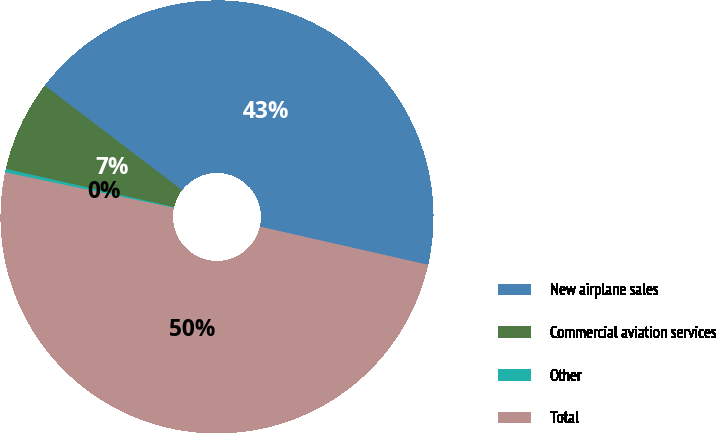Convert chart. <chart><loc_0><loc_0><loc_500><loc_500><pie_chart><fcel>New airplane sales<fcel>Commercial aviation services<fcel>Other<fcel>Total<nl><fcel>43.19%<fcel>6.81%<fcel>0.26%<fcel>49.74%<nl></chart> 